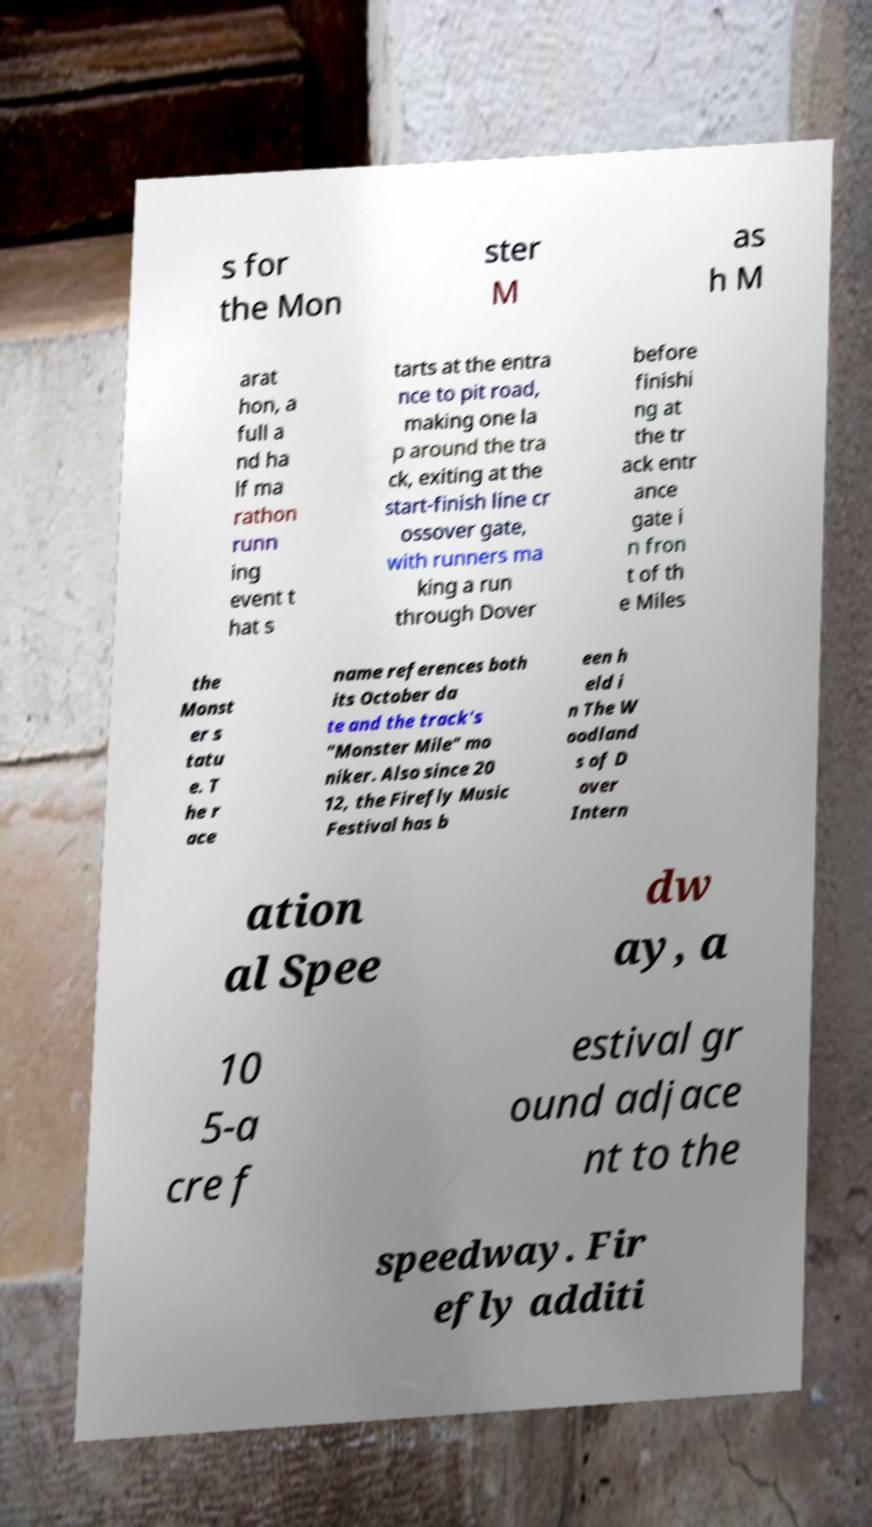Can you accurately transcribe the text from the provided image for me? s for the Mon ster M as h M arat hon, a full a nd ha lf ma rathon runn ing event t hat s tarts at the entra nce to pit road, making one la p around the tra ck, exiting at the start-finish line cr ossover gate, with runners ma king a run through Dover before finishi ng at the tr ack entr ance gate i n fron t of th e Miles the Monst er s tatu e. T he r ace name references both its October da te and the track's "Monster Mile" mo niker. Also since 20 12, the Firefly Music Festival has b een h eld i n The W oodland s of D over Intern ation al Spee dw ay, a 10 5-a cre f estival gr ound adjace nt to the speedway. Fir efly additi 